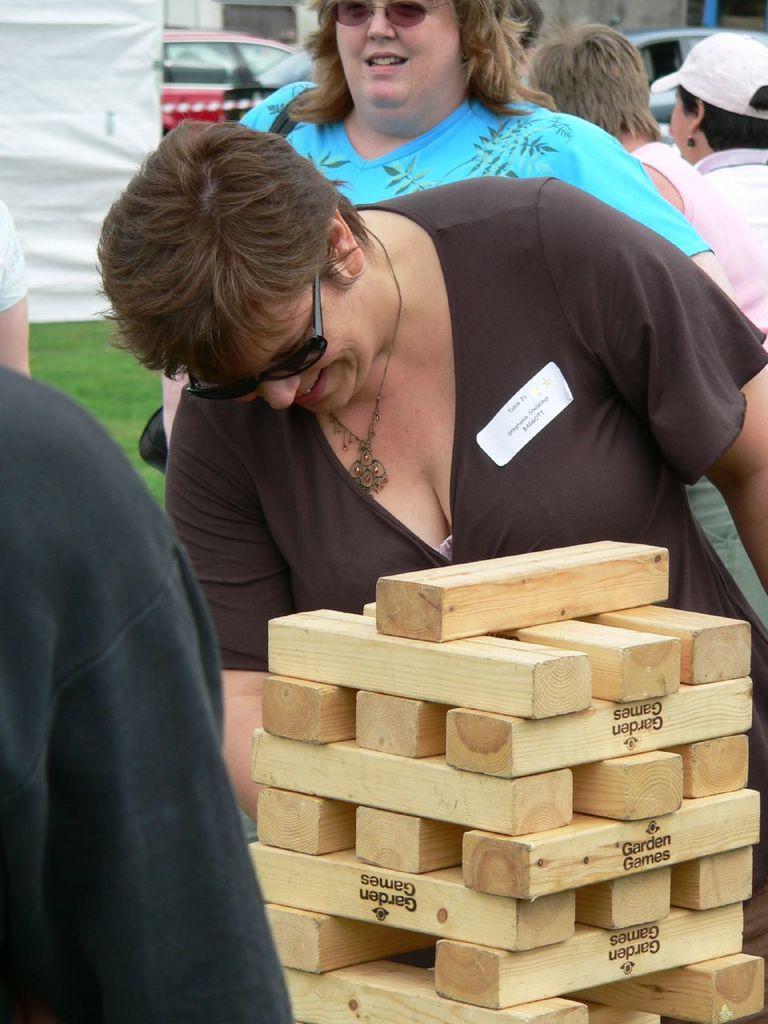Describe this image in one or two sentences. In this image we can see a group of people standing. On the bottom of the image we can see the structure built with some small wooden pieces and some text on it. On the backside we can see some grass, a wall and some cars. 